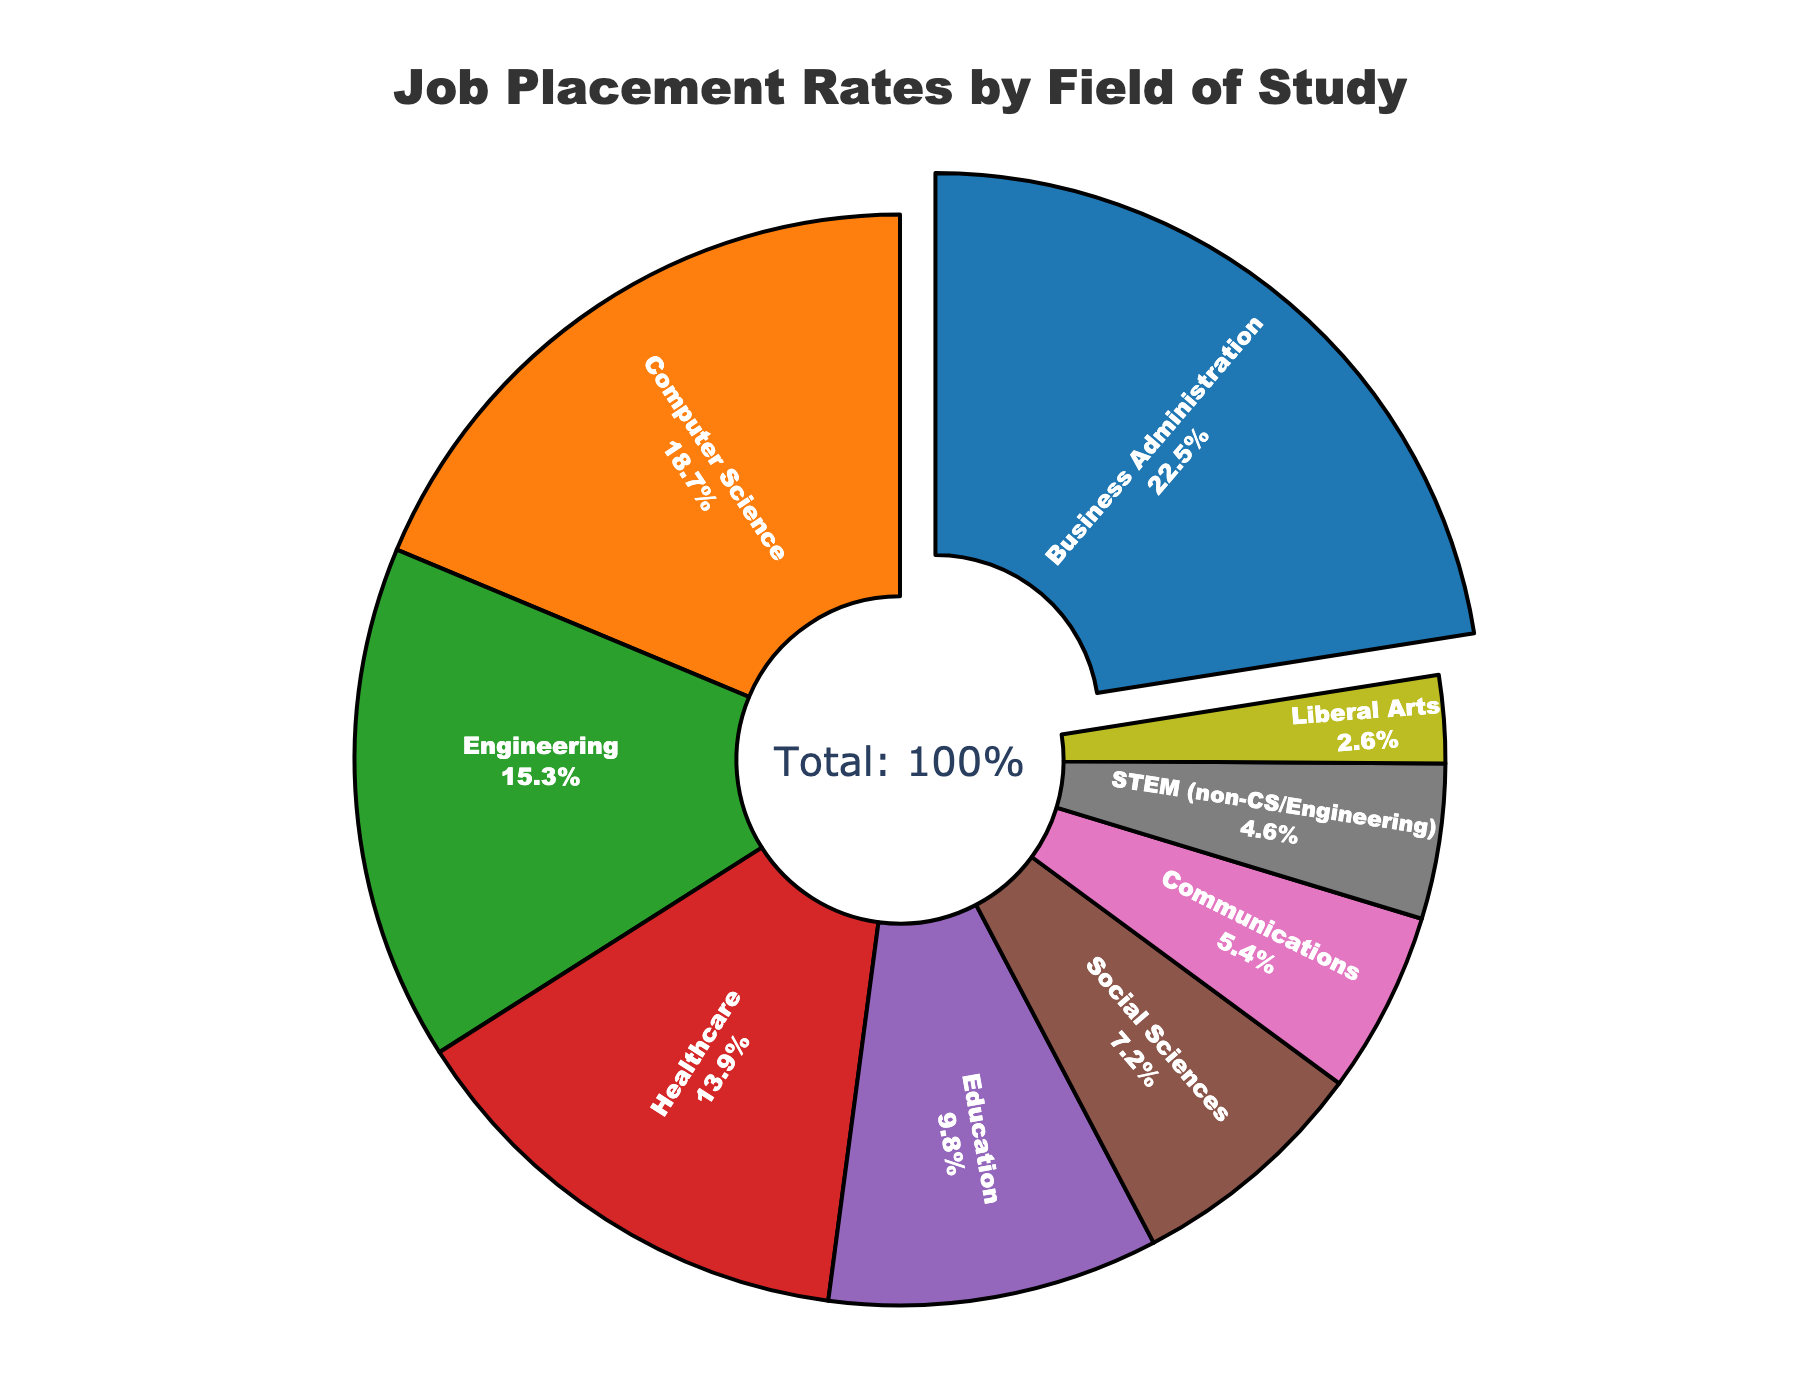How many fields of study have job placement rates higher than 10%? Look for fields of study with placement rates above 10% and count them. Business Administration (22.5%), Computer Science (18.7%), Engineering (15.3%), and Healthcare (13.9%) are all above 10%. There are four fields in total.
Answer: 4 Which field has the highest job placement rate, and what is the value? Identify the field with the largest slice of the pie and its corresponding job placement rate. The largest slice is Business Administration with a rate of 22.5%.
Answer: Business Administration, 22.5% What is the combined job placement rate for Engineering, Healthcare, and Education? Sum the job placement rates for Engineering (15.3%), Healthcare (13.9%), and Education (9.8%). The combined rate is 15.3 + 13.9 + 9.8 = 39.0%.
Answer: 39.0% How does the job placement rate for STEM (non-CS/Engineering) compare to that of Communications? Compare the placement rates of STEM (non-CS/Engineering) and Communications. STEM (non-CS/Engineering) has a rate of 4.6%, while Communications has a rate of 5.4%. Communications has a higher placement rate.
Answer: Communications has a higher rate If you sum the job placement rates for Social Sciences and Liberal Arts, how does this total compare to the rate for Computer Science? Sum the rates for Social Sciences (7.2%) and Liberal Arts (2.6%) which equals 9.8%. Compare this total to the Computer Science rate of 18.7%. The combined rate for Social Sciences and Liberal Arts is lower.
Answer: Lower than Computer Science What colors represent the fields with the top three job placement rates? Look at the colors of the slices for the fields with the top three job placement rates: Business Administration (dark blue), Computer Science (orange), and Engineering (green).
Answer: Dark blue, orange, green Which field has the smallest job placement rate and what percentage does it represent? Identify the smallest slice in the pie chart and its job placement rate. The smallest slice is Liberal Arts with a rate of 2.6%.
Answer: Liberal Arts, 2.6% What is the median job placement rate among all fields of study? List the placement rates in numerical order: 2.6%, 4.6%, 5.4%, 7.2%, 9.8%, 13.9%, 15.3%, 18.7%, 22.5%. The middle value in this ordered list is 9.8% (Education).
Answer: 9.8% How much higher is the job placement rate for Business Administration compared to Education? Subtract the job placement rate of Education (9.8%) from that of Business Administration (22.5%). The difference is 22.5 - 9.8 = 12.7%.
Answer: 12.7% What is the job placement rate for the field represented in red? Identify the slice colored red in the pie chart and its corresponding field. Healthcare is colored red with a job placement rate of 13.9%.
Answer: 13.9% 